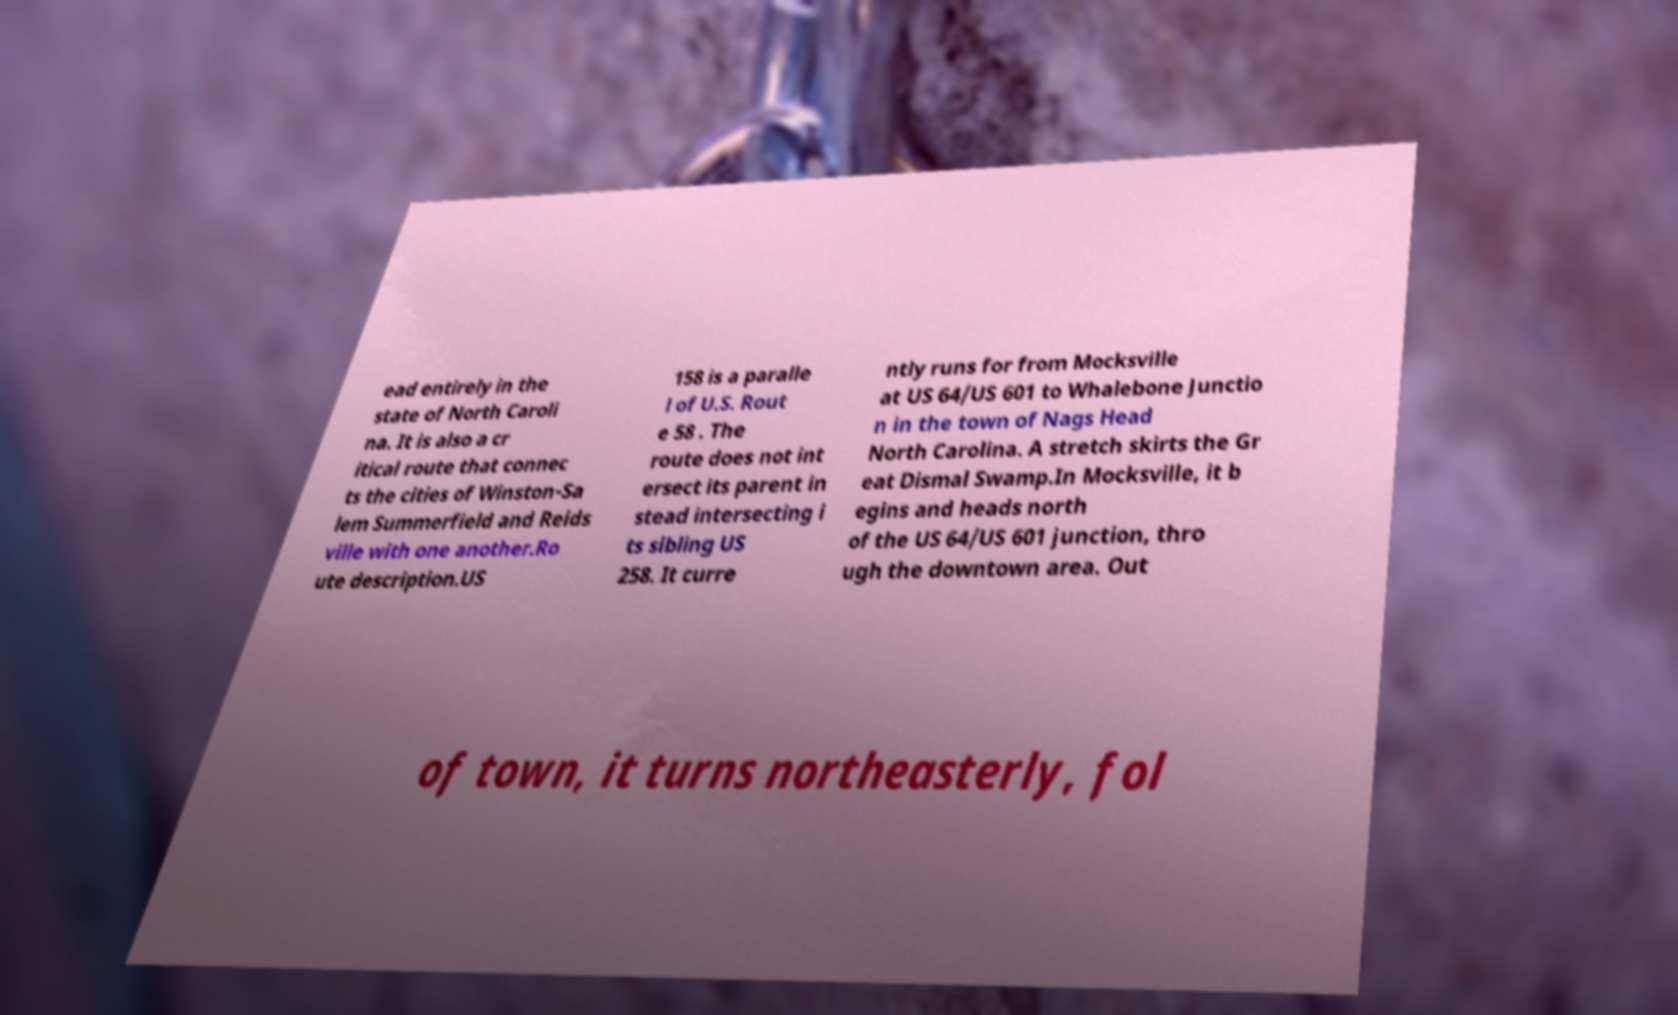For documentation purposes, I need the text within this image transcribed. Could you provide that? ead entirely in the state of North Caroli na. It is also a cr itical route that connec ts the cities of Winston-Sa lem Summerfield and Reids ville with one another.Ro ute description.US 158 is a paralle l of U.S. Rout e 58 . The route does not int ersect its parent in stead intersecting i ts sibling US 258. It curre ntly runs for from Mocksville at US 64/US 601 to Whalebone Junctio n in the town of Nags Head North Carolina. A stretch skirts the Gr eat Dismal Swamp.In Mocksville, it b egins and heads north of the US 64/US 601 junction, thro ugh the downtown area. Out of town, it turns northeasterly, fol 